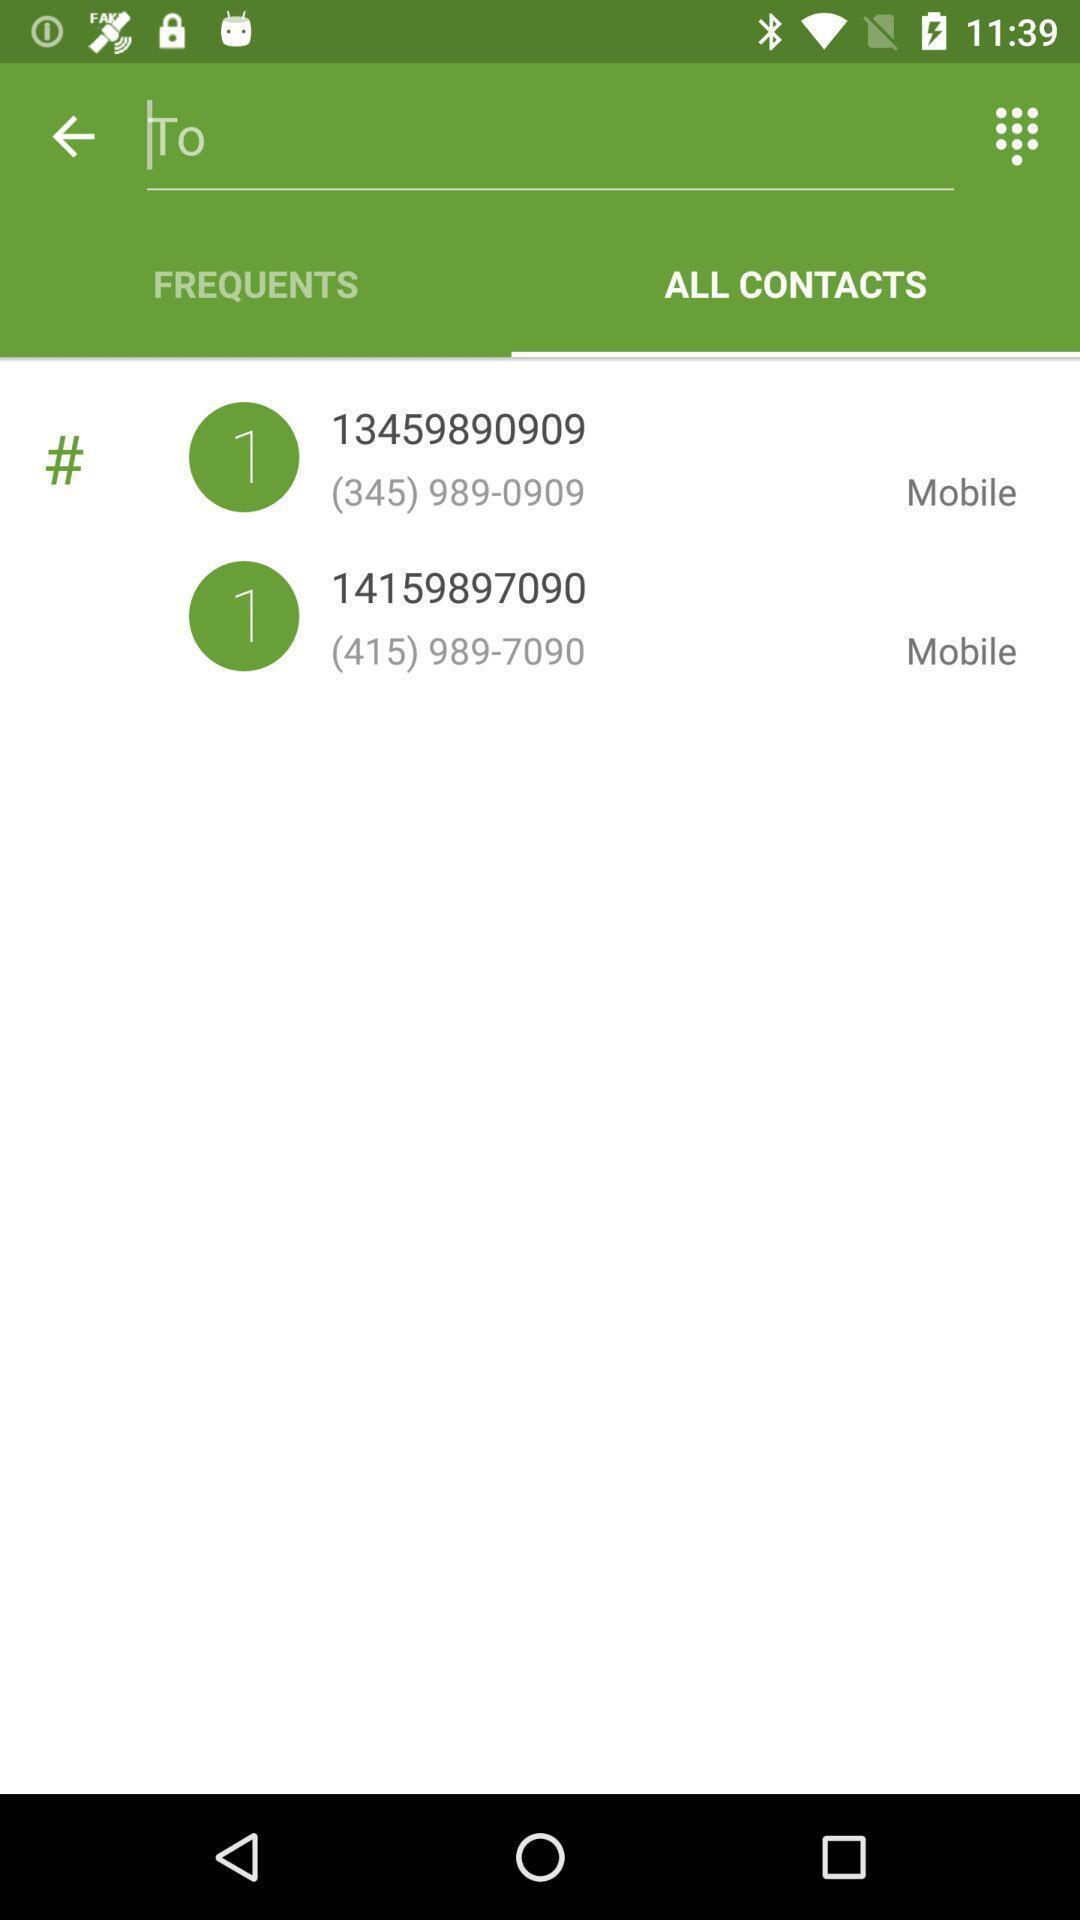Summarize the information in this screenshot. Search page of a contacts app. 